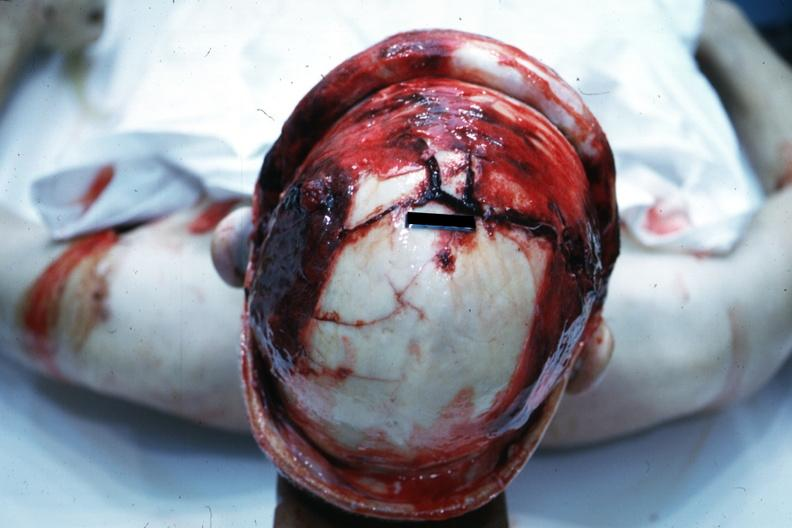what is present?
Answer the question using a single word or phrase. Bone 